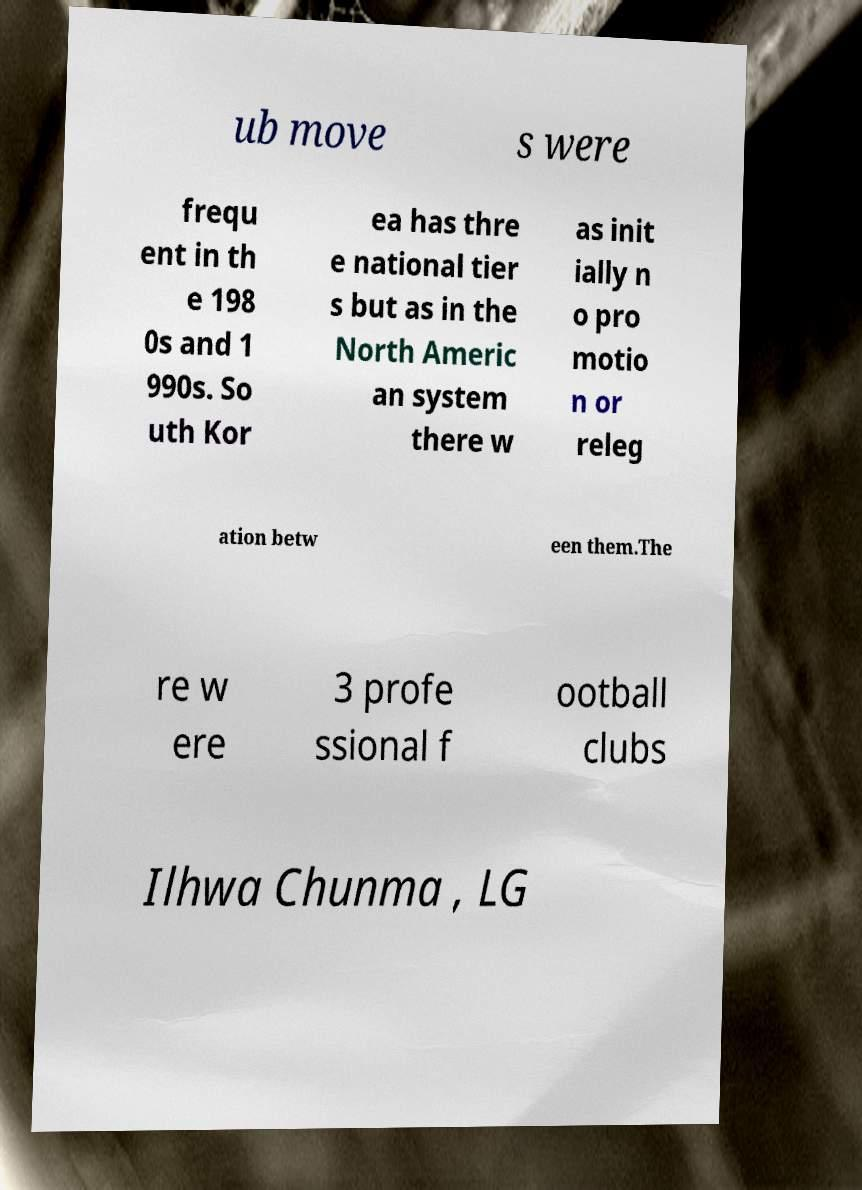There's text embedded in this image that I need extracted. Can you transcribe it verbatim? ub move s were frequ ent in th e 198 0s and 1 990s. So uth Kor ea has thre e national tier s but as in the North Americ an system there w as init ially n o pro motio n or releg ation betw een them.The re w ere 3 profe ssional f ootball clubs Ilhwa Chunma , LG 